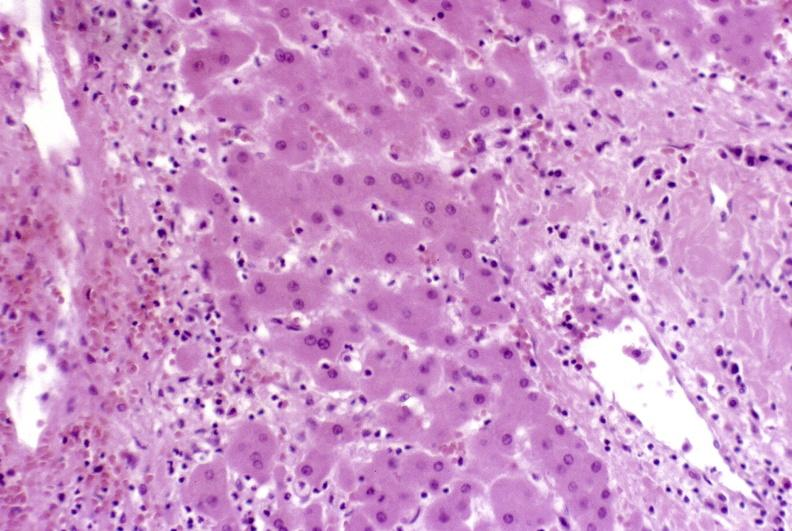what is present?
Answer the question using a single word or phrase. Liver 